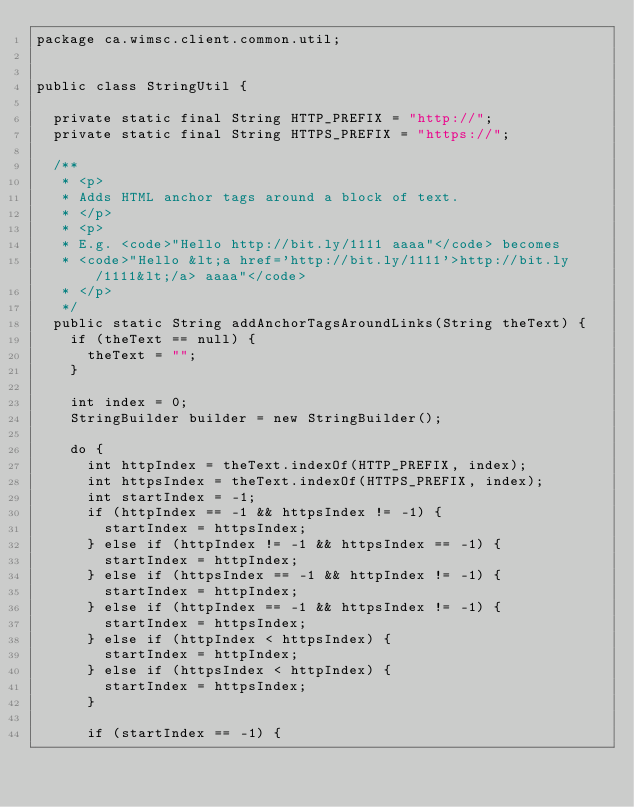<code> <loc_0><loc_0><loc_500><loc_500><_Java_>package ca.wimsc.client.common.util;


public class StringUtil {

	private static final String HTTP_PREFIX = "http://";
	private static final String HTTPS_PREFIX = "https://";

	/**
	 * <p>
	 * Adds HTML anchor tags around a block of text.
	 * </p>
	 * <p>
	 * E.g. <code>"Hello http://bit.ly/1111 aaaa"</code> becomes
	 * <code>"Hello &lt;a href='http://bit.ly/1111'>http://bit.ly/1111&lt;/a> aaaa"</code>
	 * </p>
	 */
	public static String addAnchorTagsAroundLinks(String theText) {
		if (theText == null) {
			theText = "";
		}

		int index = 0;
		StringBuilder builder = new StringBuilder();

		do {
			int httpIndex = theText.indexOf(HTTP_PREFIX, index);
			int httpsIndex = theText.indexOf(HTTPS_PREFIX, index);
			int startIndex = -1;
			if (httpIndex == -1 && httpsIndex != -1) {
				startIndex = httpsIndex;
			} else if (httpIndex != -1 && httpsIndex == -1) {
				startIndex = httpIndex;
			} else if (httpsIndex == -1 && httpIndex != -1) {
				startIndex = httpIndex;
			} else if (httpIndex == -1 && httpsIndex != -1) {
				startIndex = httpsIndex;
			} else if (httpIndex < httpsIndex) {
				startIndex = httpIndex;
			} else if (httpsIndex < httpIndex) {
				startIndex = httpsIndex;
			}

			if (startIndex == -1) {</code> 